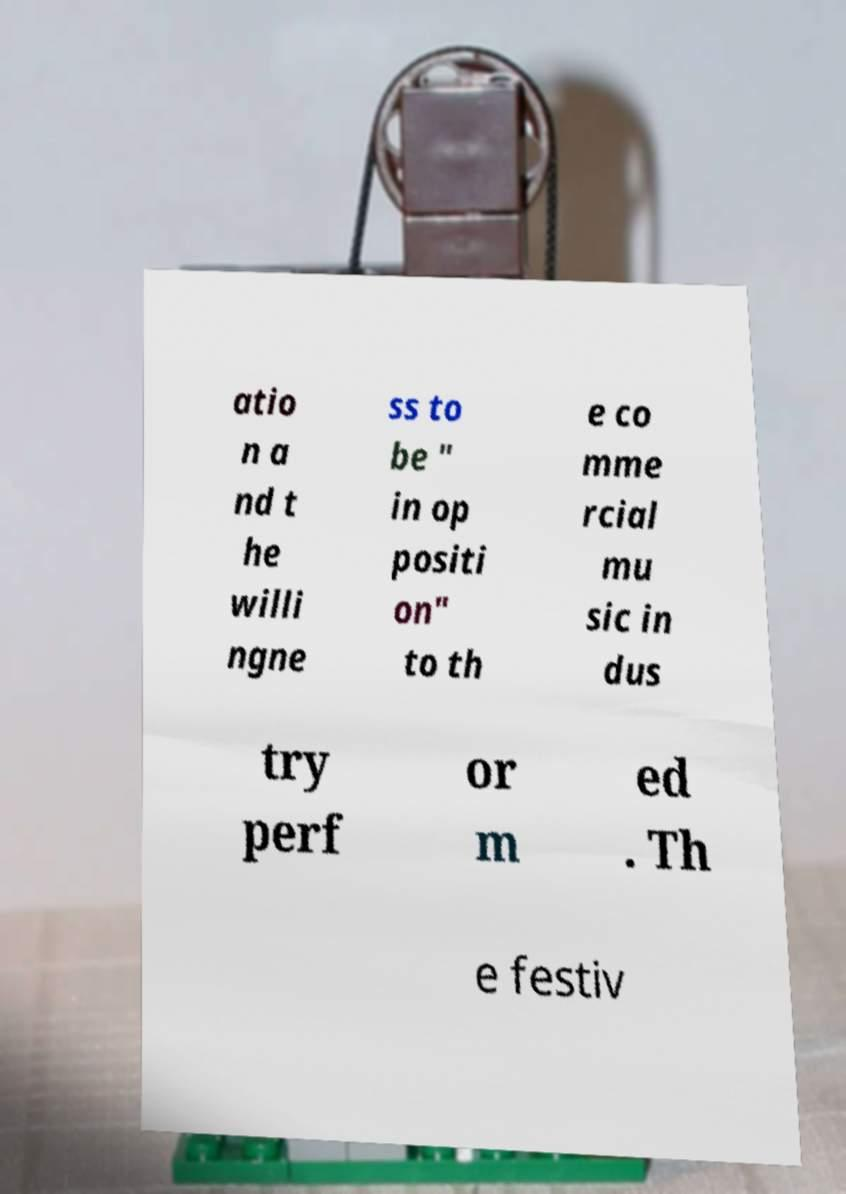Could you extract and type out the text from this image? atio n a nd t he willi ngne ss to be " in op positi on" to th e co mme rcial mu sic in dus try perf or m ed . Th e festiv 